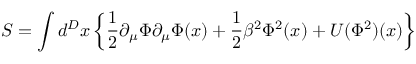<formula> <loc_0><loc_0><loc_500><loc_500>S = \int d ^ { D } x \left \{ \frac { 1 } { 2 } \partial _ { \mu } \Phi \partial _ { \mu } \Phi ( x ) + \frac { 1 } { 2 } \beta ^ { 2 } \Phi ^ { 2 } ( x ) + U ( \Phi ^ { 2 } ) ( x ) \right \}</formula> 